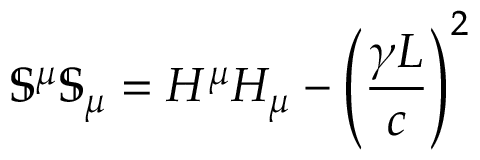<formula> <loc_0><loc_0><loc_500><loc_500>\mathbb { S } ^ { \mu } \mathbb { S } _ { \mu } = H ^ { \mu } H _ { \mu } - \left ( \frac { \gamma L } { c } \right ) ^ { 2 }</formula> 